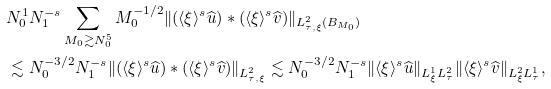<formula> <loc_0><loc_0><loc_500><loc_500>& N _ { 0 } ^ { 1 } N _ { 1 } ^ { - s } \sum _ { M _ { 0 } \gtrsim N _ { 0 } ^ { 5 } } M _ { 0 } ^ { - 1 / 2 } \| ( \langle \xi \rangle ^ { s } \widehat { u } ) * ( \langle \xi \rangle ^ { s } \widehat { v } ) \| _ { L _ { \tau , \xi } ^ { 2 } ( B _ { M _ { 0 } } ) } \\ & \lesssim N _ { 0 } ^ { - 3 / 2 } N _ { 1 } ^ { - s } \| ( \langle \xi \rangle ^ { s } \widehat { u } ) * ( \langle \xi \rangle ^ { s } \widehat { v } ) \| _ { L _ { \tau , \xi } ^ { 2 } } \lesssim N _ { 0 } ^ { - 3 / 2 } N _ { 1 } ^ { - s } \| \langle \xi \rangle ^ { s } \widehat { u } \| _ { L _ { \xi } ^ { 1 } L _ { \tau } ^ { 2 } } \| \langle \xi \rangle ^ { s } \widehat { v } \| _ { L _ { \xi } ^ { 2 } L _ { \tau } ^ { 1 } } ,</formula> 